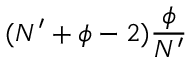Convert formula to latex. <formula><loc_0><loc_0><loc_500><loc_500>( N ^ { \prime } + \phi - 2 ) \frac { \phi } { N ^ { \prime } }</formula> 